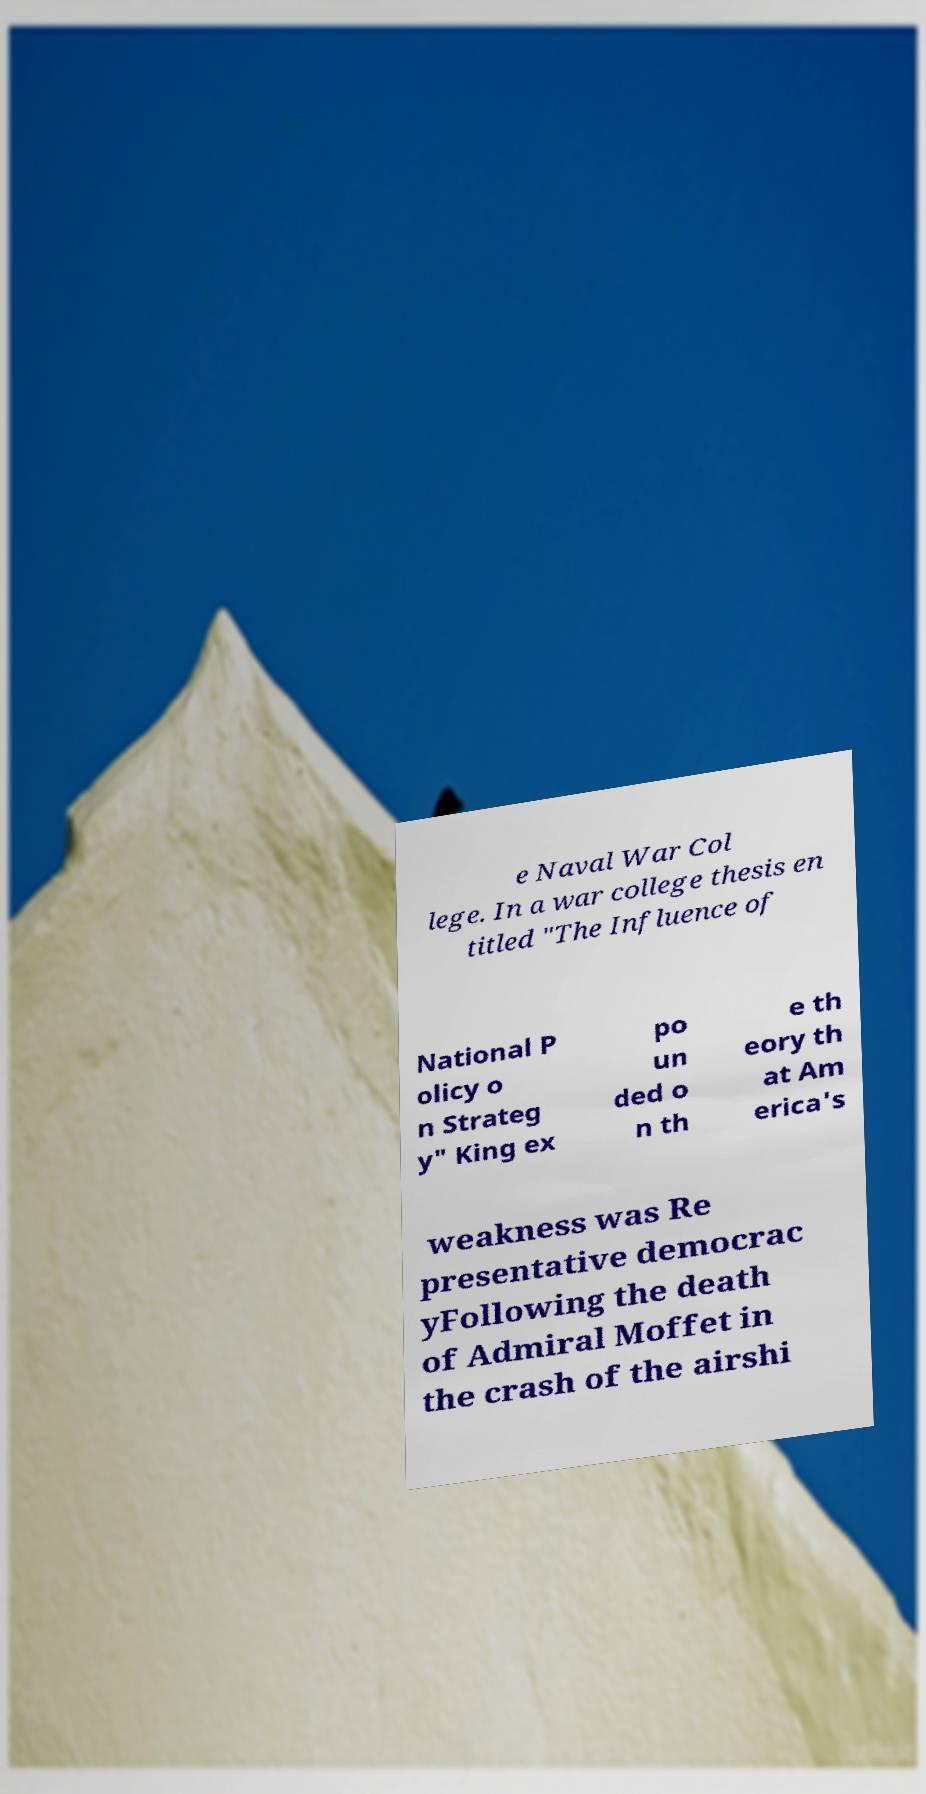What messages or text are displayed in this image? I need them in a readable, typed format. e Naval War Col lege. In a war college thesis en titled "The Influence of National P olicy o n Strateg y" King ex po un ded o n th e th eory th at Am erica's weakness was Re presentative democrac yFollowing the death of Admiral Moffet in the crash of the airshi 